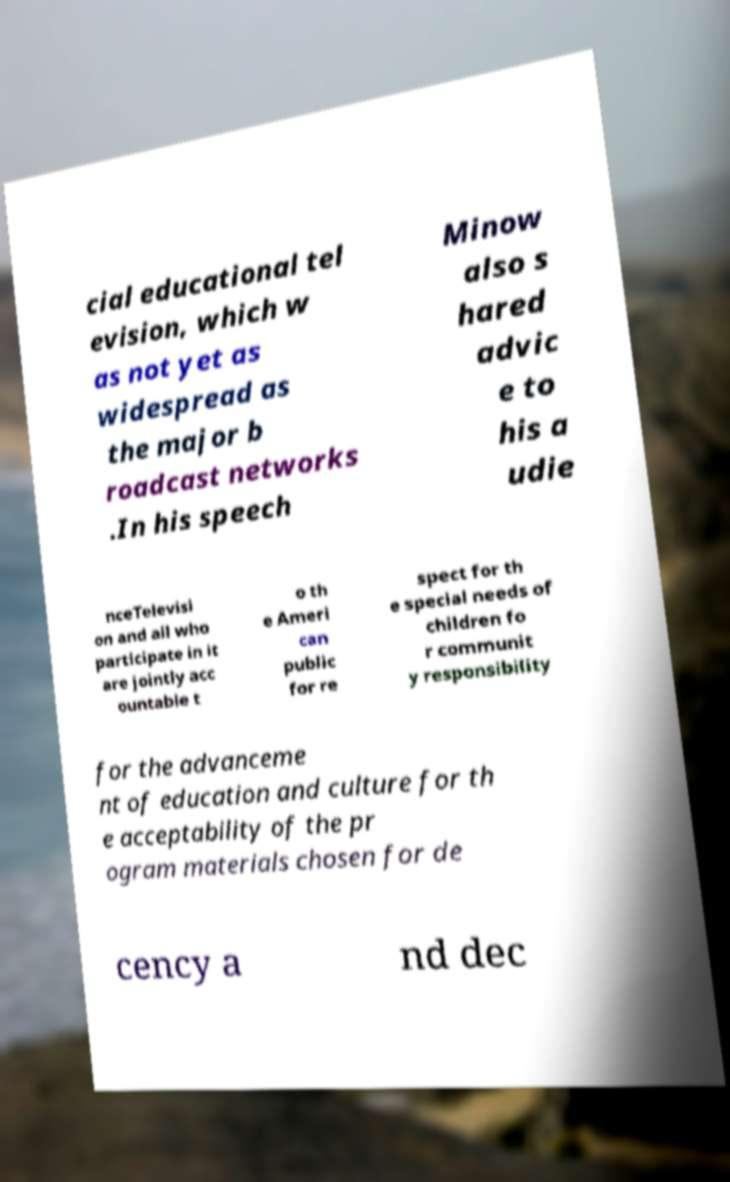There's text embedded in this image that I need extracted. Can you transcribe it verbatim? cial educational tel evision, which w as not yet as widespread as the major b roadcast networks .In his speech Minow also s hared advic e to his a udie nceTelevisi on and all who participate in it are jointly acc ountable t o th e Ameri can public for re spect for th e special needs of children fo r communit y responsibility for the advanceme nt of education and culture for th e acceptability of the pr ogram materials chosen for de cency a nd dec 